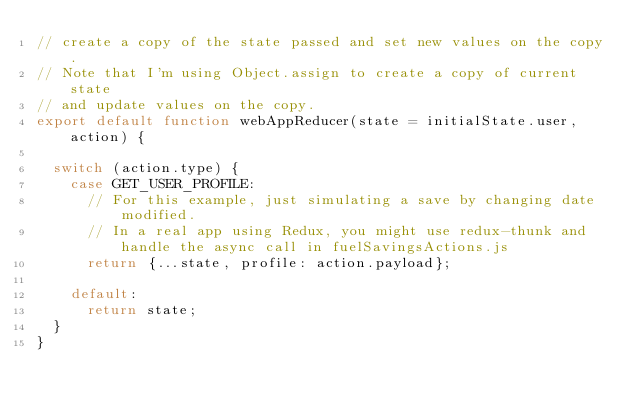<code> <loc_0><loc_0><loc_500><loc_500><_JavaScript_>// create a copy of the state passed and set new values on the copy.
// Note that I'm using Object.assign to create a copy of current state
// and update values on the copy.
export default function webAppReducer(state = initialState.user, action) {

  switch (action.type) {
    case GET_USER_PROFILE:
      // For this example, just simulating a save by changing date modified.
      // In a real app using Redux, you might use redux-thunk and handle the async call in fuelSavingsActions.js
      return {...state, profile: action.payload};

    default:
      return state;
  }
}
</code> 